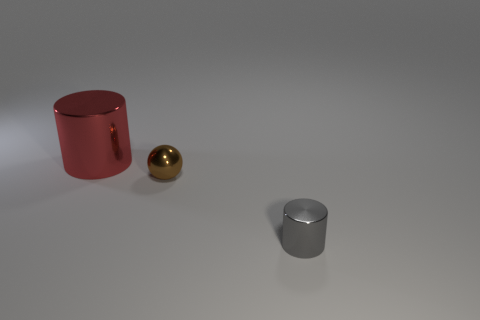Are there any other things that are the same size as the red cylinder?
Offer a terse response. No. Are there any other gray shiny things that have the same shape as the big object?
Keep it short and to the point. Yes. Is the number of tiny brown shiny spheres less than the number of yellow shiny cylinders?
Your answer should be compact. No. Does the large shiny object have the same shape as the gray object?
Offer a terse response. Yes. What number of things are either metal spheres or metallic things on the right side of the big object?
Your answer should be very brief. 2. What number of yellow matte cylinders are there?
Offer a very short reply. 0. Is there a red shiny thing that has the same size as the sphere?
Offer a terse response. No. Is the number of small metallic cylinders on the right side of the small gray object less than the number of tiny shiny cylinders?
Offer a very short reply. Yes. Do the brown metal thing and the red cylinder have the same size?
Provide a succinct answer. No. What size is the gray thing that is made of the same material as the brown sphere?
Give a very brief answer. Small. 